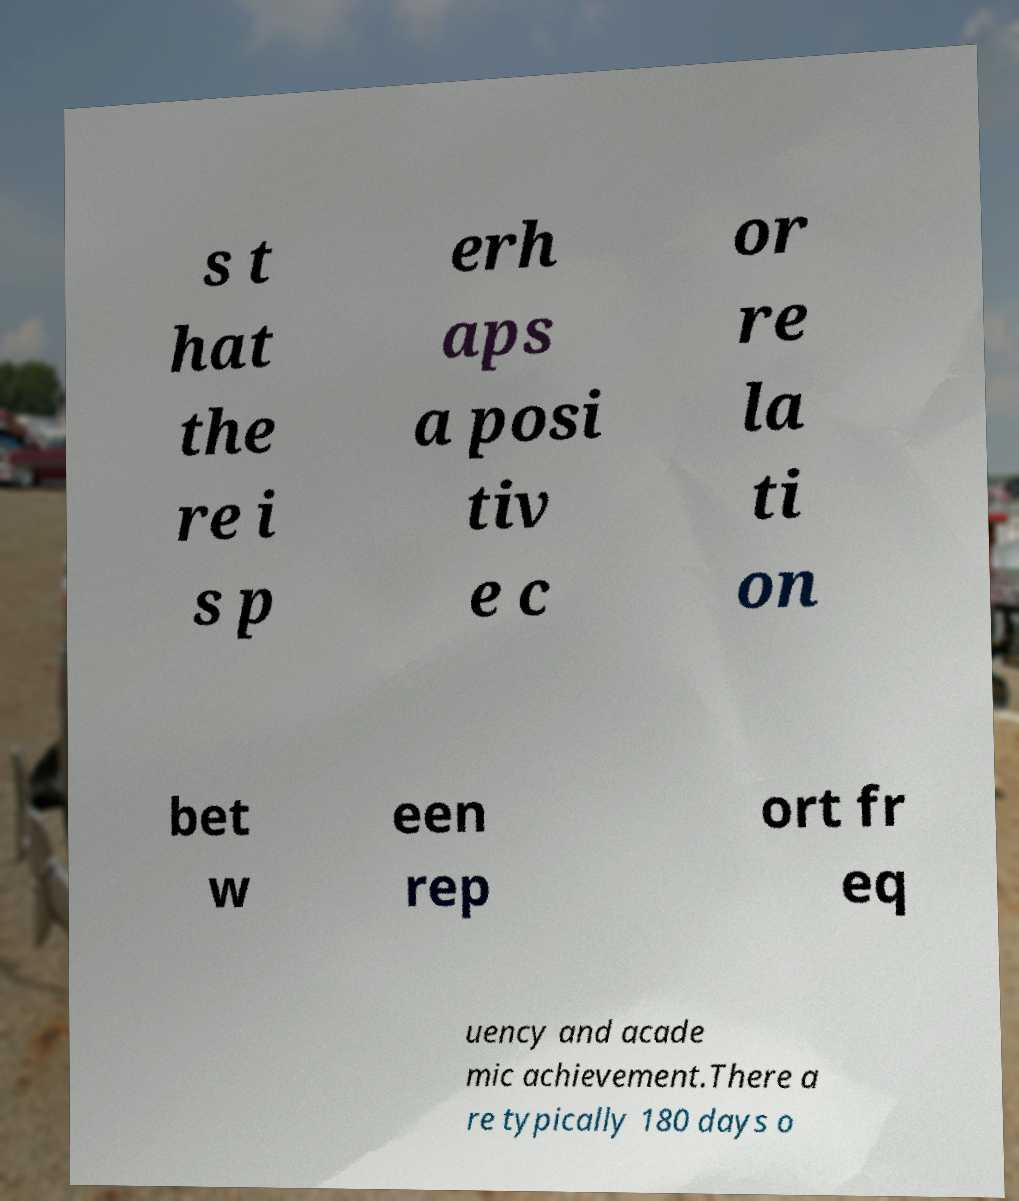Could you assist in decoding the text presented in this image and type it out clearly? s t hat the re i s p erh aps a posi tiv e c or re la ti on bet w een rep ort fr eq uency and acade mic achievement.There a re typically 180 days o 